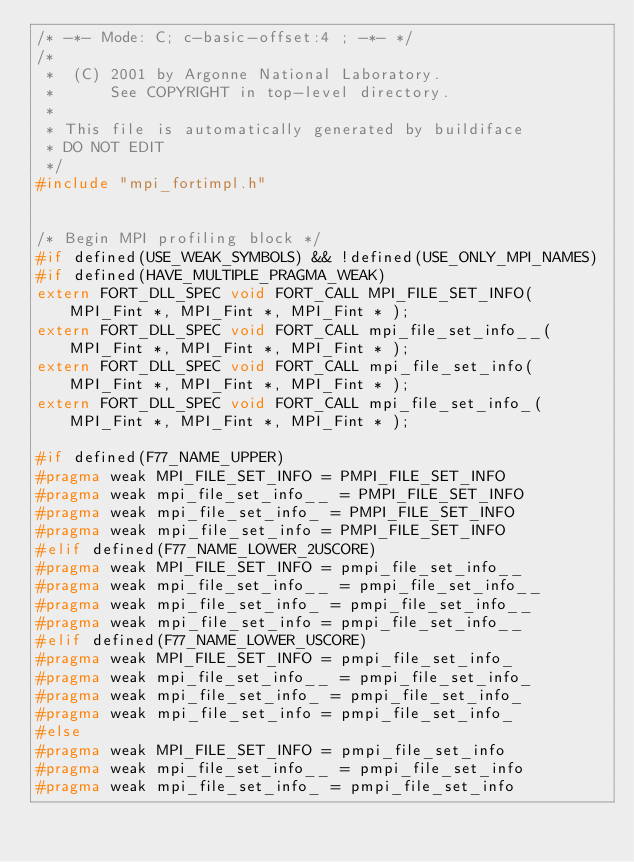Convert code to text. <code><loc_0><loc_0><loc_500><loc_500><_C_>/* -*- Mode: C; c-basic-offset:4 ; -*- */
/*  
 *  (C) 2001 by Argonne National Laboratory.
 *      See COPYRIGHT in top-level directory.
 *
 * This file is automatically generated by buildiface 
 * DO NOT EDIT
 */
#include "mpi_fortimpl.h"


/* Begin MPI profiling block */
#if defined(USE_WEAK_SYMBOLS) && !defined(USE_ONLY_MPI_NAMES) 
#if defined(HAVE_MULTIPLE_PRAGMA_WEAK)
extern FORT_DLL_SPEC void FORT_CALL MPI_FILE_SET_INFO( MPI_Fint *, MPI_Fint *, MPI_Fint * );
extern FORT_DLL_SPEC void FORT_CALL mpi_file_set_info__( MPI_Fint *, MPI_Fint *, MPI_Fint * );
extern FORT_DLL_SPEC void FORT_CALL mpi_file_set_info( MPI_Fint *, MPI_Fint *, MPI_Fint * );
extern FORT_DLL_SPEC void FORT_CALL mpi_file_set_info_( MPI_Fint *, MPI_Fint *, MPI_Fint * );

#if defined(F77_NAME_UPPER)
#pragma weak MPI_FILE_SET_INFO = PMPI_FILE_SET_INFO
#pragma weak mpi_file_set_info__ = PMPI_FILE_SET_INFO
#pragma weak mpi_file_set_info_ = PMPI_FILE_SET_INFO
#pragma weak mpi_file_set_info = PMPI_FILE_SET_INFO
#elif defined(F77_NAME_LOWER_2USCORE)
#pragma weak MPI_FILE_SET_INFO = pmpi_file_set_info__
#pragma weak mpi_file_set_info__ = pmpi_file_set_info__
#pragma weak mpi_file_set_info_ = pmpi_file_set_info__
#pragma weak mpi_file_set_info = pmpi_file_set_info__
#elif defined(F77_NAME_LOWER_USCORE)
#pragma weak MPI_FILE_SET_INFO = pmpi_file_set_info_
#pragma weak mpi_file_set_info__ = pmpi_file_set_info_
#pragma weak mpi_file_set_info_ = pmpi_file_set_info_
#pragma weak mpi_file_set_info = pmpi_file_set_info_
#else
#pragma weak MPI_FILE_SET_INFO = pmpi_file_set_info
#pragma weak mpi_file_set_info__ = pmpi_file_set_info
#pragma weak mpi_file_set_info_ = pmpi_file_set_info</code> 